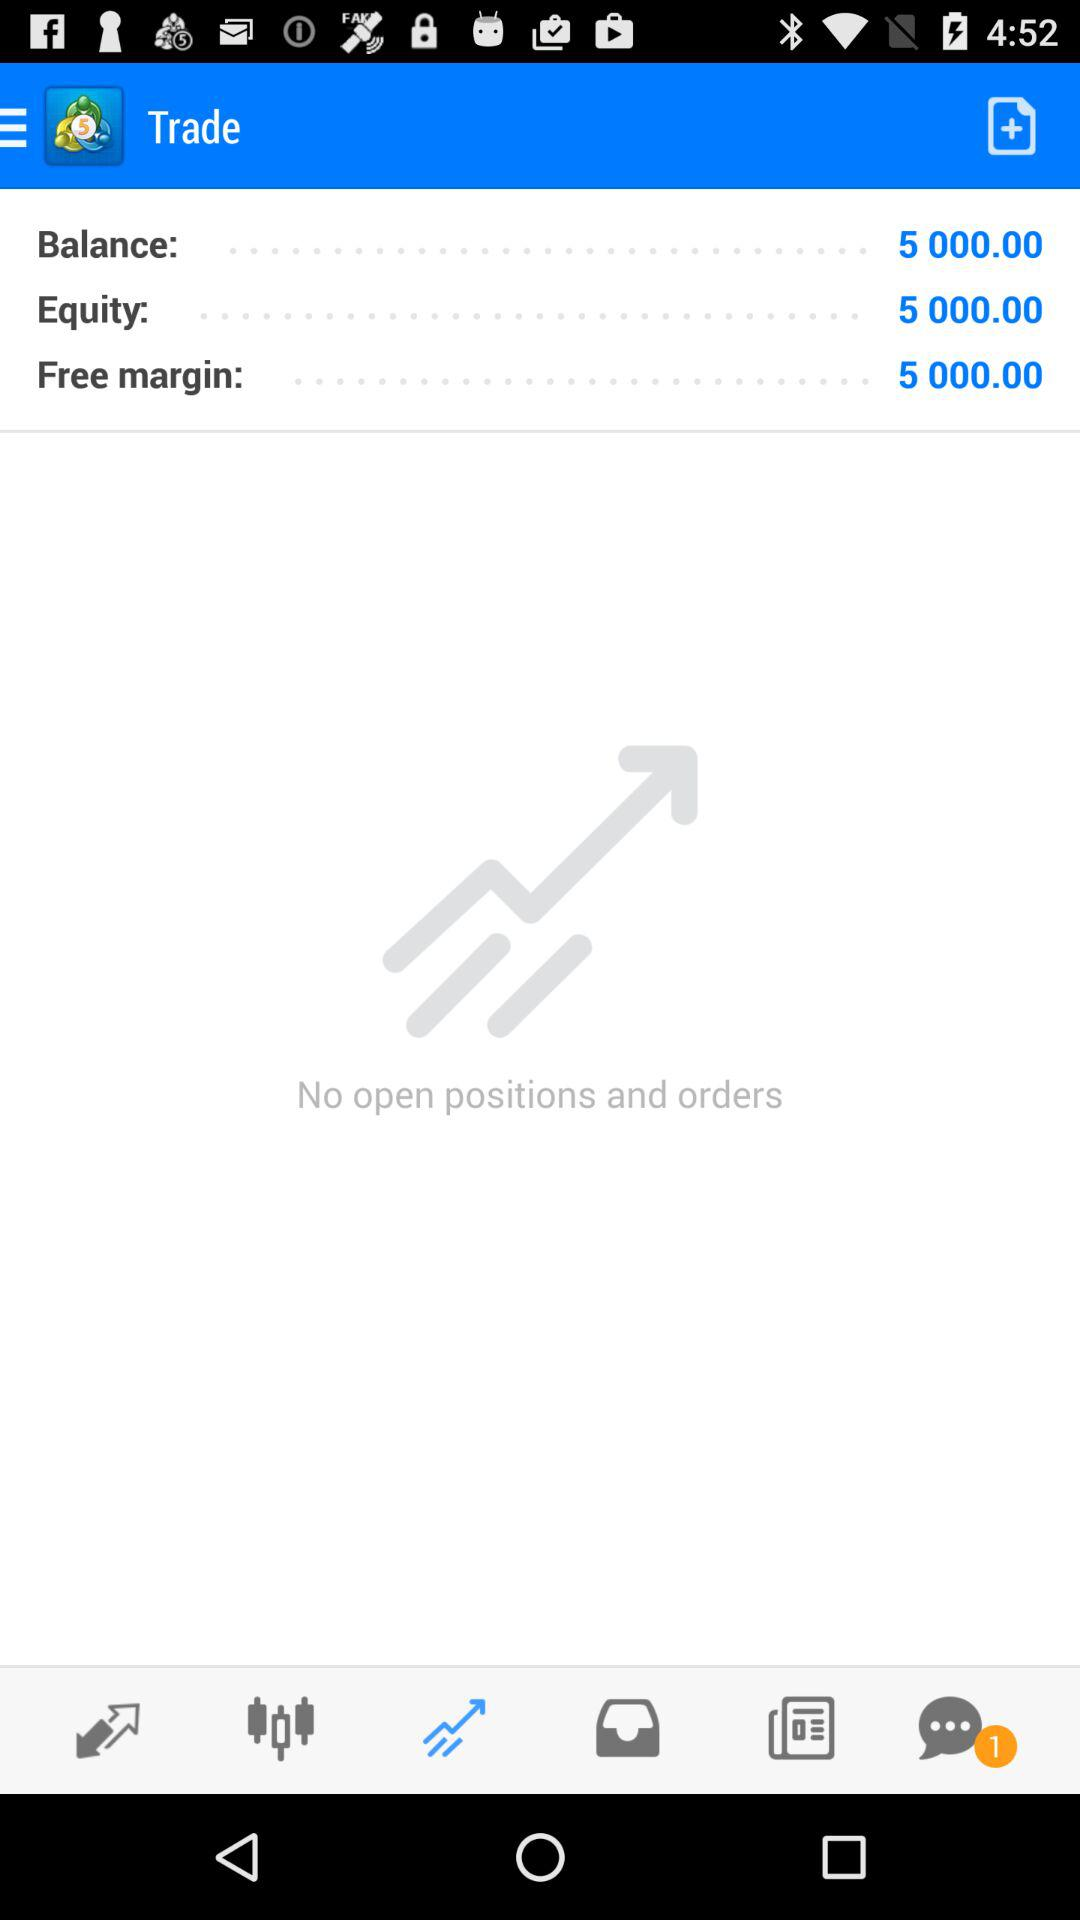Whose account is this?
When the provided information is insufficient, respond with <no answer>. <no answer> 